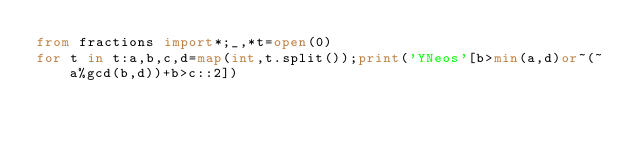Convert code to text. <code><loc_0><loc_0><loc_500><loc_500><_Python_>from fractions import*;_,*t=open(0)
for t in t:a,b,c,d=map(int,t.split());print('YNeos'[b>min(a,d)or~(~a%gcd(b,d))+b>c::2])</code> 